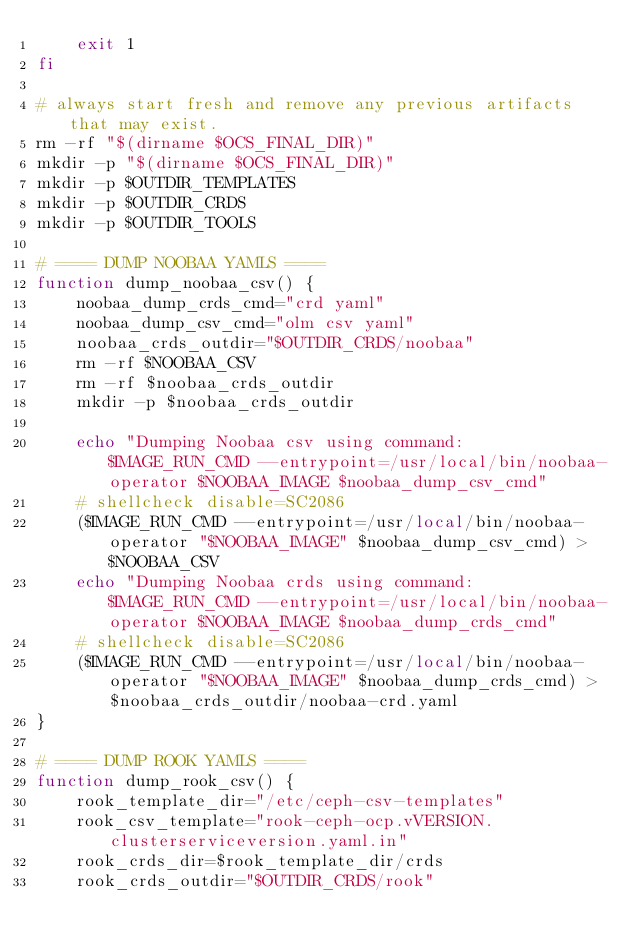Convert code to text. <code><loc_0><loc_0><loc_500><loc_500><_Bash_>	exit 1
fi

# always start fresh and remove any previous artifacts that may exist.
rm -rf "$(dirname $OCS_FINAL_DIR)"
mkdir -p "$(dirname $OCS_FINAL_DIR)"
mkdir -p $OUTDIR_TEMPLATES
mkdir -p $OUTDIR_CRDS
mkdir -p $OUTDIR_TOOLS

# ==== DUMP NOOBAA YAMLS ====
function dump_noobaa_csv() {
	noobaa_dump_crds_cmd="crd yaml"
	noobaa_dump_csv_cmd="olm csv yaml"
	noobaa_crds_outdir="$OUTDIR_CRDS/noobaa"
	rm -rf $NOOBAA_CSV
	rm -rf $noobaa_crds_outdir
	mkdir -p $noobaa_crds_outdir

	echo "Dumping Noobaa csv using command: $IMAGE_RUN_CMD --entrypoint=/usr/local/bin/noobaa-operator $NOOBAA_IMAGE $noobaa_dump_csv_cmd"
	# shellcheck disable=SC2086
	($IMAGE_RUN_CMD --entrypoint=/usr/local/bin/noobaa-operator "$NOOBAA_IMAGE" $noobaa_dump_csv_cmd) > $NOOBAA_CSV
	echo "Dumping Noobaa crds using command: $IMAGE_RUN_CMD --entrypoint=/usr/local/bin/noobaa-operator $NOOBAA_IMAGE $noobaa_dump_crds_cmd"
	# shellcheck disable=SC2086
	($IMAGE_RUN_CMD --entrypoint=/usr/local/bin/noobaa-operator "$NOOBAA_IMAGE" $noobaa_dump_crds_cmd) > $noobaa_crds_outdir/noobaa-crd.yaml
}

# ==== DUMP ROOK YAMLS ====
function dump_rook_csv() {
	rook_template_dir="/etc/ceph-csv-templates"
	rook_csv_template="rook-ceph-ocp.vVERSION.clusterserviceversion.yaml.in"
	rook_crds_dir=$rook_template_dir/crds
	rook_crds_outdir="$OUTDIR_CRDS/rook"</code> 